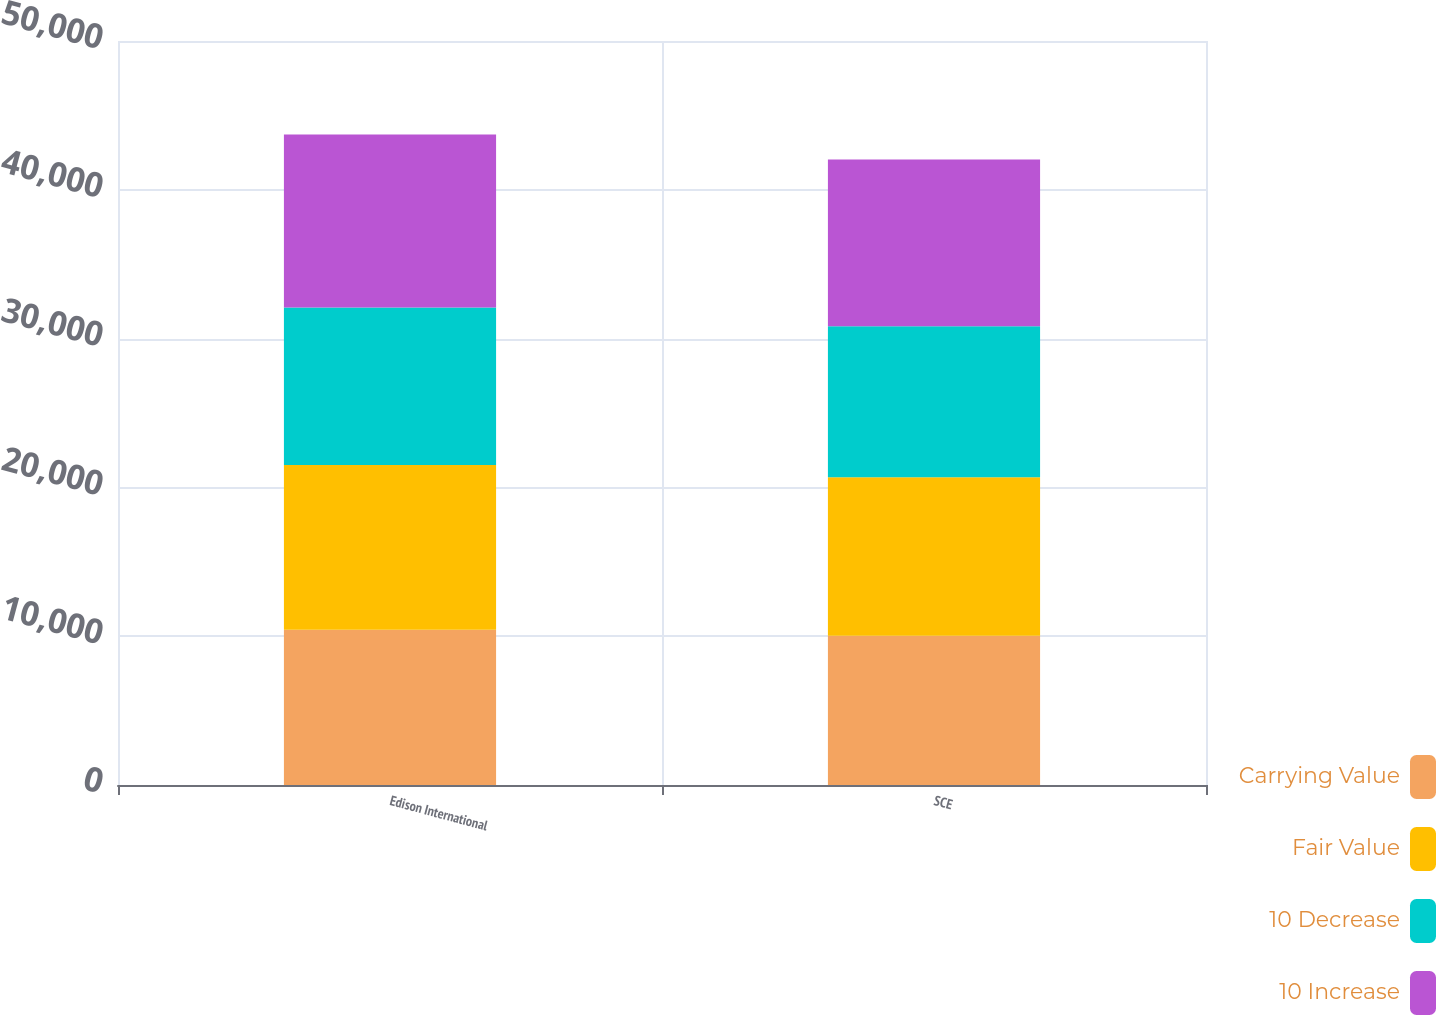<chart> <loc_0><loc_0><loc_500><loc_500><stacked_bar_chart><ecel><fcel>Edison International<fcel>SCE<nl><fcel>Carrying Value<fcel>10426<fcel>10022<nl><fcel>Fair Value<fcel>11084<fcel>10656<nl><fcel>10 Decrease<fcel>10578<fcel>10153<nl><fcel>10 Increase<fcel>11635<fcel>11204<nl></chart> 